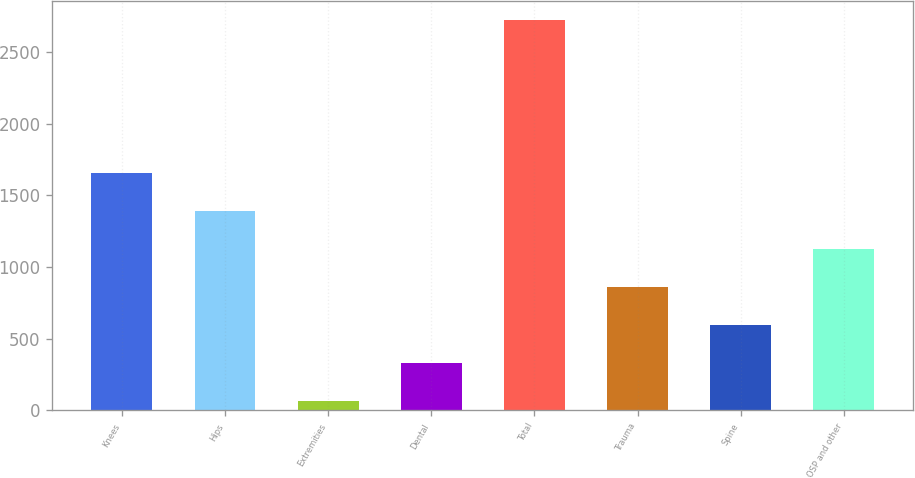Convert chart to OTSL. <chart><loc_0><loc_0><loc_500><loc_500><bar_chart><fcel>Knees<fcel>Hips<fcel>Extremities<fcel>Dental<fcel>Total<fcel>Trauma<fcel>Spine<fcel>OSP and other<nl><fcel>1659.04<fcel>1393.55<fcel>66.1<fcel>331.59<fcel>2721<fcel>862.57<fcel>597.08<fcel>1128.06<nl></chart> 